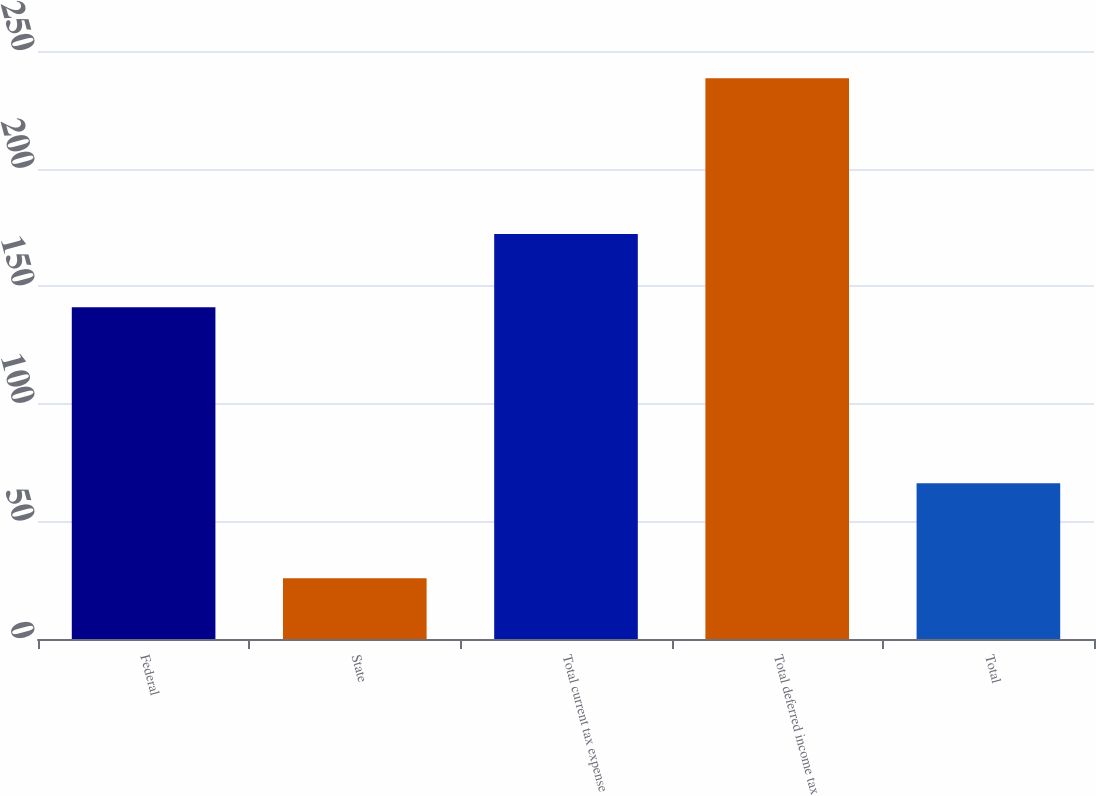Convert chart. <chart><loc_0><loc_0><loc_500><loc_500><bar_chart><fcel>Federal<fcel>State<fcel>Total current tax expense<fcel>Total deferred income tax<fcel>Total<nl><fcel>141<fcel>25.8<fcel>172.2<fcel>238.4<fcel>66.2<nl></chart> 